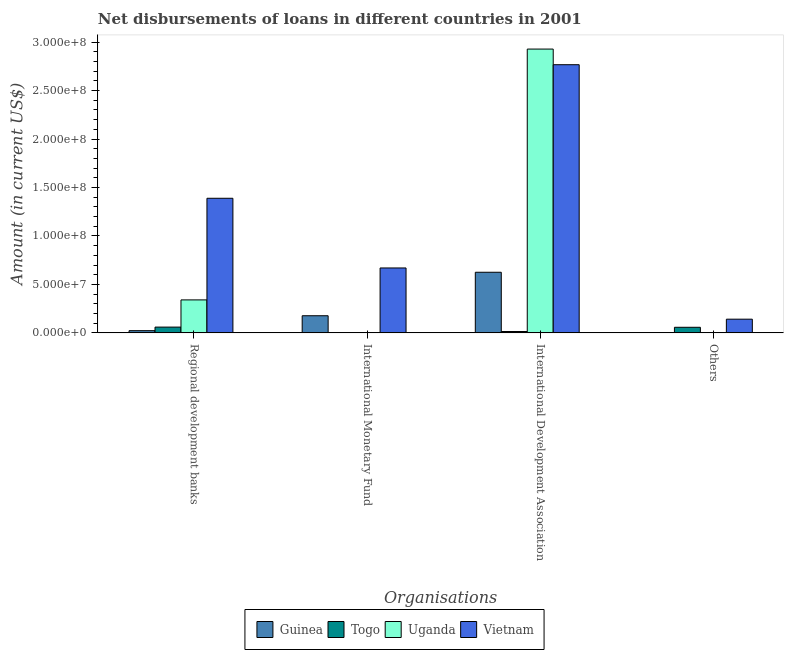How many groups of bars are there?
Ensure brevity in your answer.  4. Are the number of bars per tick equal to the number of legend labels?
Provide a short and direct response. No. Are the number of bars on each tick of the X-axis equal?
Give a very brief answer. No. What is the label of the 3rd group of bars from the left?
Your answer should be compact. International Development Association. What is the amount of loan disimbursed by international development association in Togo?
Ensure brevity in your answer.  1.41e+06. Across all countries, what is the maximum amount of loan disimbursed by international monetary fund?
Your answer should be compact. 6.70e+07. Across all countries, what is the minimum amount of loan disimbursed by international development association?
Your answer should be compact. 1.41e+06. In which country was the amount of loan disimbursed by international development association maximum?
Give a very brief answer. Uganda. What is the total amount of loan disimbursed by international monetary fund in the graph?
Your response must be concise. 8.46e+07. What is the difference between the amount of loan disimbursed by other organisations in Vietnam and that in Togo?
Make the answer very short. 8.36e+06. What is the difference between the amount of loan disimbursed by international development association in Vietnam and the amount of loan disimbursed by other organisations in Guinea?
Your answer should be very brief. 2.77e+08. What is the average amount of loan disimbursed by international monetary fund per country?
Offer a terse response. 2.12e+07. What is the difference between the amount of loan disimbursed by other organisations and amount of loan disimbursed by regional development banks in Vietnam?
Make the answer very short. -1.25e+08. What is the ratio of the amount of loan disimbursed by regional development banks in Togo to that in Vietnam?
Ensure brevity in your answer.  0.04. What is the difference between the highest and the second highest amount of loan disimbursed by regional development banks?
Make the answer very short. 1.05e+08. What is the difference between the highest and the lowest amount of loan disimbursed by international development association?
Provide a short and direct response. 2.91e+08. How many bars are there?
Your answer should be compact. 12. Are all the bars in the graph horizontal?
Keep it short and to the point. No. Does the graph contain grids?
Give a very brief answer. No. How are the legend labels stacked?
Provide a short and direct response. Horizontal. What is the title of the graph?
Your answer should be very brief. Net disbursements of loans in different countries in 2001. Does "Mozambique" appear as one of the legend labels in the graph?
Keep it short and to the point. No. What is the label or title of the X-axis?
Provide a succinct answer. Organisations. What is the label or title of the Y-axis?
Keep it short and to the point. Amount (in current US$). What is the Amount (in current US$) in Guinea in Regional development banks?
Your response must be concise. 2.28e+06. What is the Amount (in current US$) in Togo in Regional development banks?
Give a very brief answer. 5.95e+06. What is the Amount (in current US$) of Uganda in Regional development banks?
Give a very brief answer. 3.40e+07. What is the Amount (in current US$) of Vietnam in Regional development banks?
Provide a succinct answer. 1.39e+08. What is the Amount (in current US$) of Guinea in International Monetary Fund?
Offer a terse response. 1.77e+07. What is the Amount (in current US$) of Vietnam in International Monetary Fund?
Keep it short and to the point. 6.70e+07. What is the Amount (in current US$) in Guinea in International Development Association?
Your response must be concise. 6.25e+07. What is the Amount (in current US$) in Togo in International Development Association?
Give a very brief answer. 1.41e+06. What is the Amount (in current US$) in Uganda in International Development Association?
Give a very brief answer. 2.93e+08. What is the Amount (in current US$) of Vietnam in International Development Association?
Give a very brief answer. 2.77e+08. What is the Amount (in current US$) in Guinea in Others?
Make the answer very short. 0. What is the Amount (in current US$) of Togo in Others?
Make the answer very short. 5.76e+06. What is the Amount (in current US$) in Uganda in Others?
Your answer should be compact. 0. What is the Amount (in current US$) of Vietnam in Others?
Your answer should be very brief. 1.41e+07. Across all Organisations, what is the maximum Amount (in current US$) of Guinea?
Make the answer very short. 6.25e+07. Across all Organisations, what is the maximum Amount (in current US$) in Togo?
Give a very brief answer. 5.95e+06. Across all Organisations, what is the maximum Amount (in current US$) of Uganda?
Ensure brevity in your answer.  2.93e+08. Across all Organisations, what is the maximum Amount (in current US$) of Vietnam?
Your answer should be compact. 2.77e+08. Across all Organisations, what is the minimum Amount (in current US$) in Togo?
Give a very brief answer. 0. Across all Organisations, what is the minimum Amount (in current US$) of Vietnam?
Offer a very short reply. 1.41e+07. What is the total Amount (in current US$) of Guinea in the graph?
Ensure brevity in your answer.  8.25e+07. What is the total Amount (in current US$) in Togo in the graph?
Offer a very short reply. 1.31e+07. What is the total Amount (in current US$) of Uganda in the graph?
Give a very brief answer. 3.27e+08. What is the total Amount (in current US$) in Vietnam in the graph?
Provide a short and direct response. 4.97e+08. What is the difference between the Amount (in current US$) in Guinea in Regional development banks and that in International Monetary Fund?
Provide a succinct answer. -1.54e+07. What is the difference between the Amount (in current US$) of Vietnam in Regional development banks and that in International Monetary Fund?
Provide a succinct answer. 7.19e+07. What is the difference between the Amount (in current US$) in Guinea in Regional development banks and that in International Development Association?
Your answer should be very brief. -6.03e+07. What is the difference between the Amount (in current US$) in Togo in Regional development banks and that in International Development Association?
Provide a short and direct response. 4.54e+06. What is the difference between the Amount (in current US$) in Uganda in Regional development banks and that in International Development Association?
Provide a short and direct response. -2.59e+08. What is the difference between the Amount (in current US$) in Vietnam in Regional development banks and that in International Development Association?
Your answer should be very brief. -1.38e+08. What is the difference between the Amount (in current US$) of Togo in Regional development banks and that in Others?
Offer a very short reply. 1.90e+05. What is the difference between the Amount (in current US$) of Vietnam in Regional development banks and that in Others?
Your response must be concise. 1.25e+08. What is the difference between the Amount (in current US$) in Guinea in International Monetary Fund and that in International Development Association?
Give a very brief answer. -4.49e+07. What is the difference between the Amount (in current US$) of Vietnam in International Monetary Fund and that in International Development Association?
Keep it short and to the point. -2.10e+08. What is the difference between the Amount (in current US$) of Vietnam in International Monetary Fund and that in Others?
Offer a very short reply. 5.28e+07. What is the difference between the Amount (in current US$) of Togo in International Development Association and that in Others?
Make the answer very short. -4.35e+06. What is the difference between the Amount (in current US$) of Vietnam in International Development Association and that in Others?
Provide a succinct answer. 2.63e+08. What is the difference between the Amount (in current US$) of Guinea in Regional development banks and the Amount (in current US$) of Vietnam in International Monetary Fund?
Offer a very short reply. -6.47e+07. What is the difference between the Amount (in current US$) in Togo in Regional development banks and the Amount (in current US$) in Vietnam in International Monetary Fund?
Your answer should be compact. -6.10e+07. What is the difference between the Amount (in current US$) of Uganda in Regional development banks and the Amount (in current US$) of Vietnam in International Monetary Fund?
Ensure brevity in your answer.  -3.30e+07. What is the difference between the Amount (in current US$) in Guinea in Regional development banks and the Amount (in current US$) in Togo in International Development Association?
Ensure brevity in your answer.  8.67e+05. What is the difference between the Amount (in current US$) of Guinea in Regional development banks and the Amount (in current US$) of Uganda in International Development Association?
Ensure brevity in your answer.  -2.91e+08. What is the difference between the Amount (in current US$) in Guinea in Regional development banks and the Amount (in current US$) in Vietnam in International Development Association?
Provide a short and direct response. -2.74e+08. What is the difference between the Amount (in current US$) of Togo in Regional development banks and the Amount (in current US$) of Uganda in International Development Association?
Offer a very short reply. -2.87e+08. What is the difference between the Amount (in current US$) in Togo in Regional development banks and the Amount (in current US$) in Vietnam in International Development Association?
Make the answer very short. -2.71e+08. What is the difference between the Amount (in current US$) in Uganda in Regional development banks and the Amount (in current US$) in Vietnam in International Development Association?
Ensure brevity in your answer.  -2.43e+08. What is the difference between the Amount (in current US$) in Guinea in Regional development banks and the Amount (in current US$) in Togo in Others?
Your answer should be compact. -3.48e+06. What is the difference between the Amount (in current US$) in Guinea in Regional development banks and the Amount (in current US$) in Vietnam in Others?
Your response must be concise. -1.18e+07. What is the difference between the Amount (in current US$) in Togo in Regional development banks and the Amount (in current US$) in Vietnam in Others?
Make the answer very short. -8.17e+06. What is the difference between the Amount (in current US$) in Uganda in Regional development banks and the Amount (in current US$) in Vietnam in Others?
Offer a very short reply. 1.99e+07. What is the difference between the Amount (in current US$) in Guinea in International Monetary Fund and the Amount (in current US$) in Togo in International Development Association?
Ensure brevity in your answer.  1.63e+07. What is the difference between the Amount (in current US$) of Guinea in International Monetary Fund and the Amount (in current US$) of Uganda in International Development Association?
Offer a very short reply. -2.75e+08. What is the difference between the Amount (in current US$) of Guinea in International Monetary Fund and the Amount (in current US$) of Vietnam in International Development Association?
Your answer should be compact. -2.59e+08. What is the difference between the Amount (in current US$) in Guinea in International Monetary Fund and the Amount (in current US$) in Togo in Others?
Make the answer very short. 1.19e+07. What is the difference between the Amount (in current US$) of Guinea in International Monetary Fund and the Amount (in current US$) of Vietnam in Others?
Provide a succinct answer. 3.55e+06. What is the difference between the Amount (in current US$) in Guinea in International Development Association and the Amount (in current US$) in Togo in Others?
Keep it short and to the point. 5.68e+07. What is the difference between the Amount (in current US$) in Guinea in International Development Association and the Amount (in current US$) in Vietnam in Others?
Your response must be concise. 4.84e+07. What is the difference between the Amount (in current US$) in Togo in International Development Association and the Amount (in current US$) in Vietnam in Others?
Your response must be concise. -1.27e+07. What is the difference between the Amount (in current US$) in Uganda in International Development Association and the Amount (in current US$) in Vietnam in Others?
Give a very brief answer. 2.79e+08. What is the average Amount (in current US$) in Guinea per Organisations?
Give a very brief answer. 2.06e+07. What is the average Amount (in current US$) of Togo per Organisations?
Your answer should be very brief. 3.28e+06. What is the average Amount (in current US$) in Uganda per Organisations?
Your answer should be very brief. 8.17e+07. What is the average Amount (in current US$) of Vietnam per Organisations?
Provide a short and direct response. 1.24e+08. What is the difference between the Amount (in current US$) in Guinea and Amount (in current US$) in Togo in Regional development banks?
Make the answer very short. -3.67e+06. What is the difference between the Amount (in current US$) in Guinea and Amount (in current US$) in Uganda in Regional development banks?
Provide a succinct answer. -3.17e+07. What is the difference between the Amount (in current US$) of Guinea and Amount (in current US$) of Vietnam in Regional development banks?
Your answer should be compact. -1.37e+08. What is the difference between the Amount (in current US$) of Togo and Amount (in current US$) of Uganda in Regional development banks?
Your response must be concise. -2.81e+07. What is the difference between the Amount (in current US$) in Togo and Amount (in current US$) in Vietnam in Regional development banks?
Give a very brief answer. -1.33e+08. What is the difference between the Amount (in current US$) of Uganda and Amount (in current US$) of Vietnam in Regional development banks?
Make the answer very short. -1.05e+08. What is the difference between the Amount (in current US$) of Guinea and Amount (in current US$) of Vietnam in International Monetary Fund?
Keep it short and to the point. -4.93e+07. What is the difference between the Amount (in current US$) of Guinea and Amount (in current US$) of Togo in International Development Association?
Your response must be concise. 6.11e+07. What is the difference between the Amount (in current US$) of Guinea and Amount (in current US$) of Uganda in International Development Association?
Your response must be concise. -2.30e+08. What is the difference between the Amount (in current US$) in Guinea and Amount (in current US$) in Vietnam in International Development Association?
Your response must be concise. -2.14e+08. What is the difference between the Amount (in current US$) in Togo and Amount (in current US$) in Uganda in International Development Association?
Give a very brief answer. -2.91e+08. What is the difference between the Amount (in current US$) of Togo and Amount (in current US$) of Vietnam in International Development Association?
Your answer should be compact. -2.75e+08. What is the difference between the Amount (in current US$) in Uganda and Amount (in current US$) in Vietnam in International Development Association?
Offer a very short reply. 1.61e+07. What is the difference between the Amount (in current US$) in Togo and Amount (in current US$) in Vietnam in Others?
Offer a very short reply. -8.36e+06. What is the ratio of the Amount (in current US$) of Guinea in Regional development banks to that in International Monetary Fund?
Ensure brevity in your answer.  0.13. What is the ratio of the Amount (in current US$) of Vietnam in Regional development banks to that in International Monetary Fund?
Provide a short and direct response. 2.07. What is the ratio of the Amount (in current US$) in Guinea in Regional development banks to that in International Development Association?
Make the answer very short. 0.04. What is the ratio of the Amount (in current US$) in Togo in Regional development banks to that in International Development Association?
Offer a very short reply. 4.22. What is the ratio of the Amount (in current US$) in Uganda in Regional development banks to that in International Development Association?
Your answer should be very brief. 0.12. What is the ratio of the Amount (in current US$) in Vietnam in Regional development banks to that in International Development Association?
Your answer should be compact. 0.5. What is the ratio of the Amount (in current US$) in Togo in Regional development banks to that in Others?
Ensure brevity in your answer.  1.03. What is the ratio of the Amount (in current US$) in Vietnam in Regional development banks to that in Others?
Provide a short and direct response. 9.84. What is the ratio of the Amount (in current US$) in Guinea in International Monetary Fund to that in International Development Association?
Provide a succinct answer. 0.28. What is the ratio of the Amount (in current US$) in Vietnam in International Monetary Fund to that in International Development Association?
Offer a very short reply. 0.24. What is the ratio of the Amount (in current US$) of Vietnam in International Monetary Fund to that in Others?
Your answer should be compact. 4.74. What is the ratio of the Amount (in current US$) of Togo in International Development Association to that in Others?
Ensure brevity in your answer.  0.24. What is the ratio of the Amount (in current US$) of Vietnam in International Development Association to that in Others?
Keep it short and to the point. 19.6. What is the difference between the highest and the second highest Amount (in current US$) of Guinea?
Your answer should be very brief. 4.49e+07. What is the difference between the highest and the second highest Amount (in current US$) of Vietnam?
Your answer should be very brief. 1.38e+08. What is the difference between the highest and the lowest Amount (in current US$) of Guinea?
Make the answer very short. 6.25e+07. What is the difference between the highest and the lowest Amount (in current US$) in Togo?
Your answer should be very brief. 5.95e+06. What is the difference between the highest and the lowest Amount (in current US$) of Uganda?
Your answer should be very brief. 2.93e+08. What is the difference between the highest and the lowest Amount (in current US$) in Vietnam?
Provide a short and direct response. 2.63e+08. 